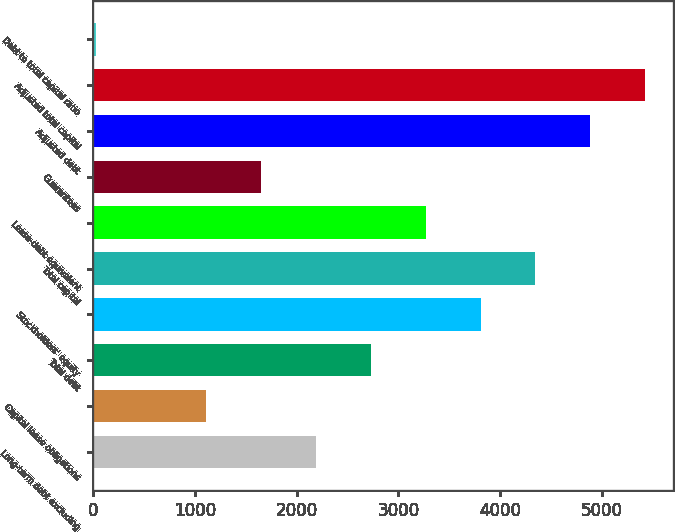<chart> <loc_0><loc_0><loc_500><loc_500><bar_chart><fcel>Long-term debt excluding<fcel>Capital lease obligations<fcel>Total debt<fcel>Stockholders' equity<fcel>Total capital<fcel>Lease-debt equivalent<fcel>Guarantees<fcel>Adjusted debt<fcel>Adjusted total capital<fcel>Debt to total capital ratio<nl><fcel>2189.04<fcel>1110.52<fcel>2728.3<fcel>3806.82<fcel>4346.08<fcel>3267.56<fcel>1649.78<fcel>4885.34<fcel>5424.6<fcel>32<nl></chart> 